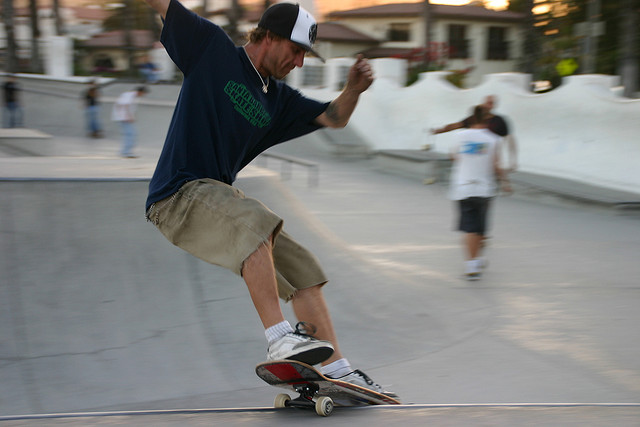Please transcribe the text information in this image. Santa Skate 